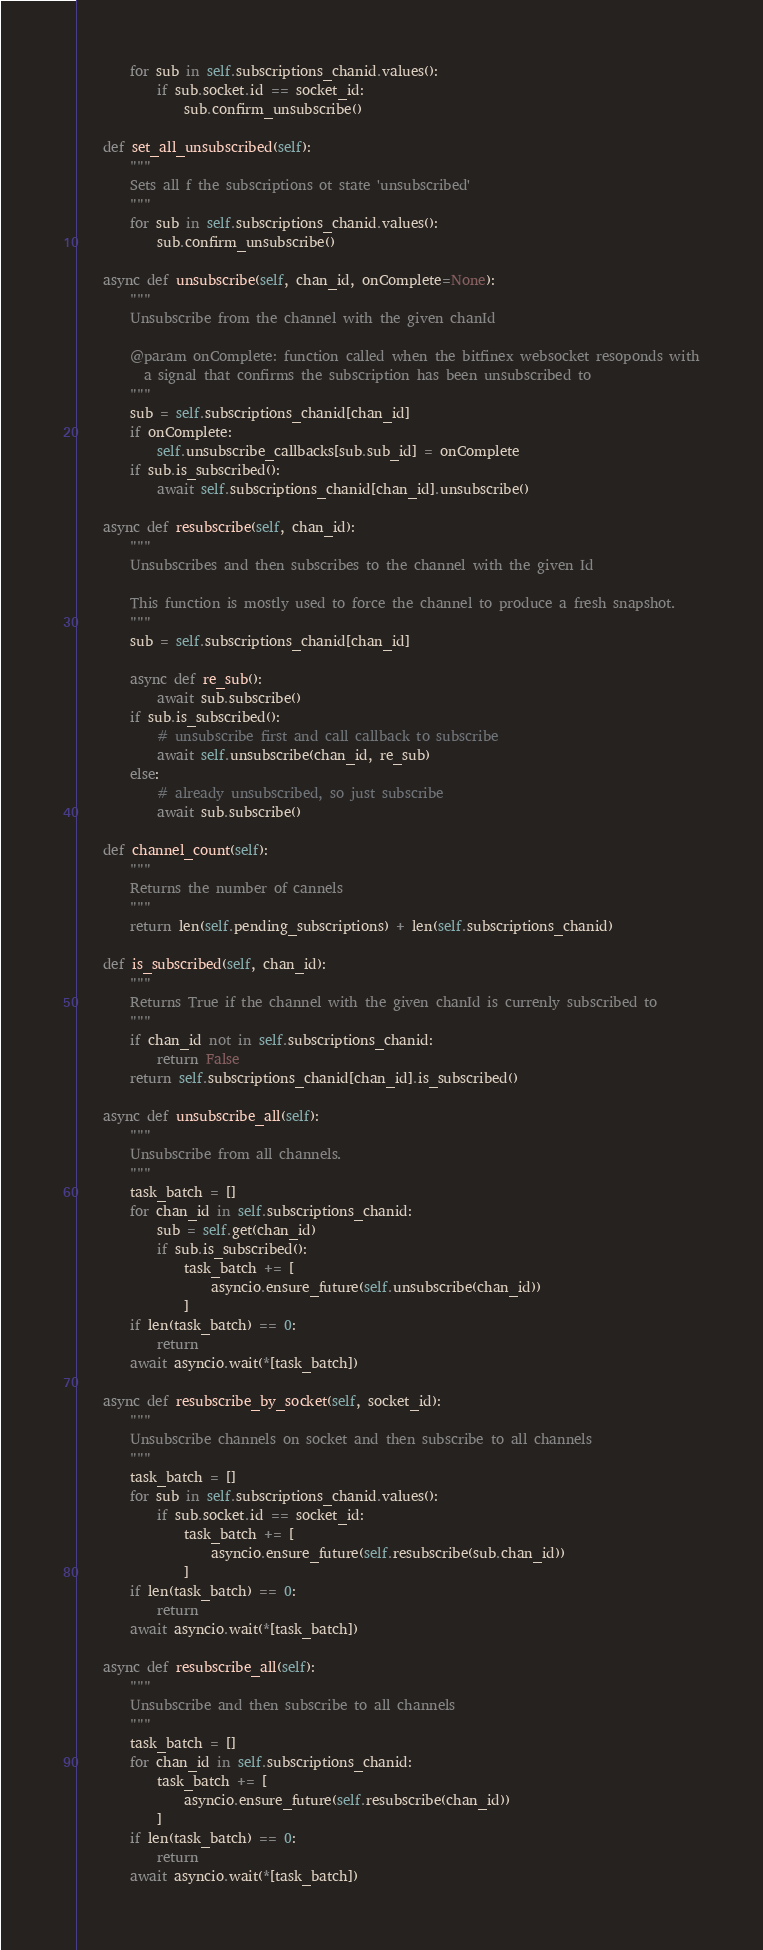Convert code to text. <code><loc_0><loc_0><loc_500><loc_500><_Python_>        for sub in self.subscriptions_chanid.values():
            if sub.socket.id == socket_id:
                sub.confirm_unsubscribe()

    def set_all_unsubscribed(self):
        """
        Sets all f the subscriptions ot state 'unsubscribed'
        """
        for sub in self.subscriptions_chanid.values():
            sub.confirm_unsubscribe()

    async def unsubscribe(self, chan_id, onComplete=None):
        """
        Unsubscribe from the channel with the given chanId

        @param onComplete: function called when the bitfinex websocket resoponds with
          a signal that confirms the subscription has been unsubscribed to
        """
        sub = self.subscriptions_chanid[chan_id]
        if onComplete:
            self.unsubscribe_callbacks[sub.sub_id] = onComplete
        if sub.is_subscribed():
            await self.subscriptions_chanid[chan_id].unsubscribe()

    async def resubscribe(self, chan_id):
        """
        Unsubscribes and then subscribes to the channel with the given Id

        This function is mostly used to force the channel to produce a fresh snapshot.
        """
        sub = self.subscriptions_chanid[chan_id]

        async def re_sub():
            await sub.subscribe()
        if sub.is_subscribed():
            # unsubscribe first and call callback to subscribe
            await self.unsubscribe(chan_id, re_sub)
        else:
            # already unsubscribed, so just subscribe
            await sub.subscribe()

    def channel_count(self):
        """
        Returns the number of cannels
        """
        return len(self.pending_subscriptions) + len(self.subscriptions_chanid)

    def is_subscribed(self, chan_id):
        """
        Returns True if the channel with the given chanId is currenly subscribed to
        """
        if chan_id not in self.subscriptions_chanid:
            return False
        return self.subscriptions_chanid[chan_id].is_subscribed()

    async def unsubscribe_all(self):
        """
        Unsubscribe from all channels.
        """
        task_batch = []
        for chan_id in self.subscriptions_chanid:
            sub = self.get(chan_id)
            if sub.is_subscribed():
                task_batch += [
                    asyncio.ensure_future(self.unsubscribe(chan_id))
                ]
        if len(task_batch) == 0:
            return
        await asyncio.wait(*[task_batch])

    async def resubscribe_by_socket(self, socket_id):
        """
        Unsubscribe channels on socket and then subscribe to all channels
        """
        task_batch = []
        for sub in self.subscriptions_chanid.values():
            if sub.socket.id == socket_id:
                task_batch += [
                    asyncio.ensure_future(self.resubscribe(sub.chan_id))
                ]
        if len(task_batch) == 0:
            return
        await asyncio.wait(*[task_batch])

    async def resubscribe_all(self):
        """
        Unsubscribe and then subscribe to all channels
        """
        task_batch = []
        for chan_id in self.subscriptions_chanid:
            task_batch += [
                asyncio.ensure_future(self.resubscribe(chan_id))
            ]
        if len(task_batch) == 0:
            return
        await asyncio.wait(*[task_batch])
</code> 